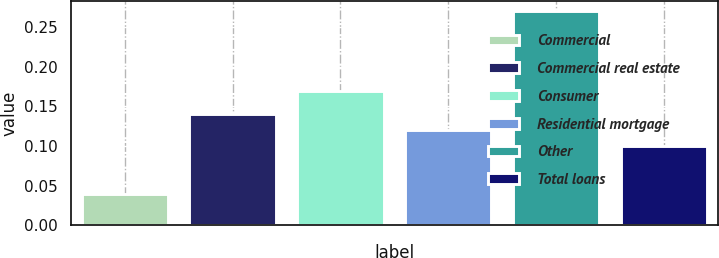<chart> <loc_0><loc_0><loc_500><loc_500><bar_chart><fcel>Commercial<fcel>Commercial real estate<fcel>Consumer<fcel>Residential mortgage<fcel>Other<fcel>Total loans<nl><fcel>0.04<fcel>0.14<fcel>0.17<fcel>0.12<fcel>0.27<fcel>0.1<nl></chart> 